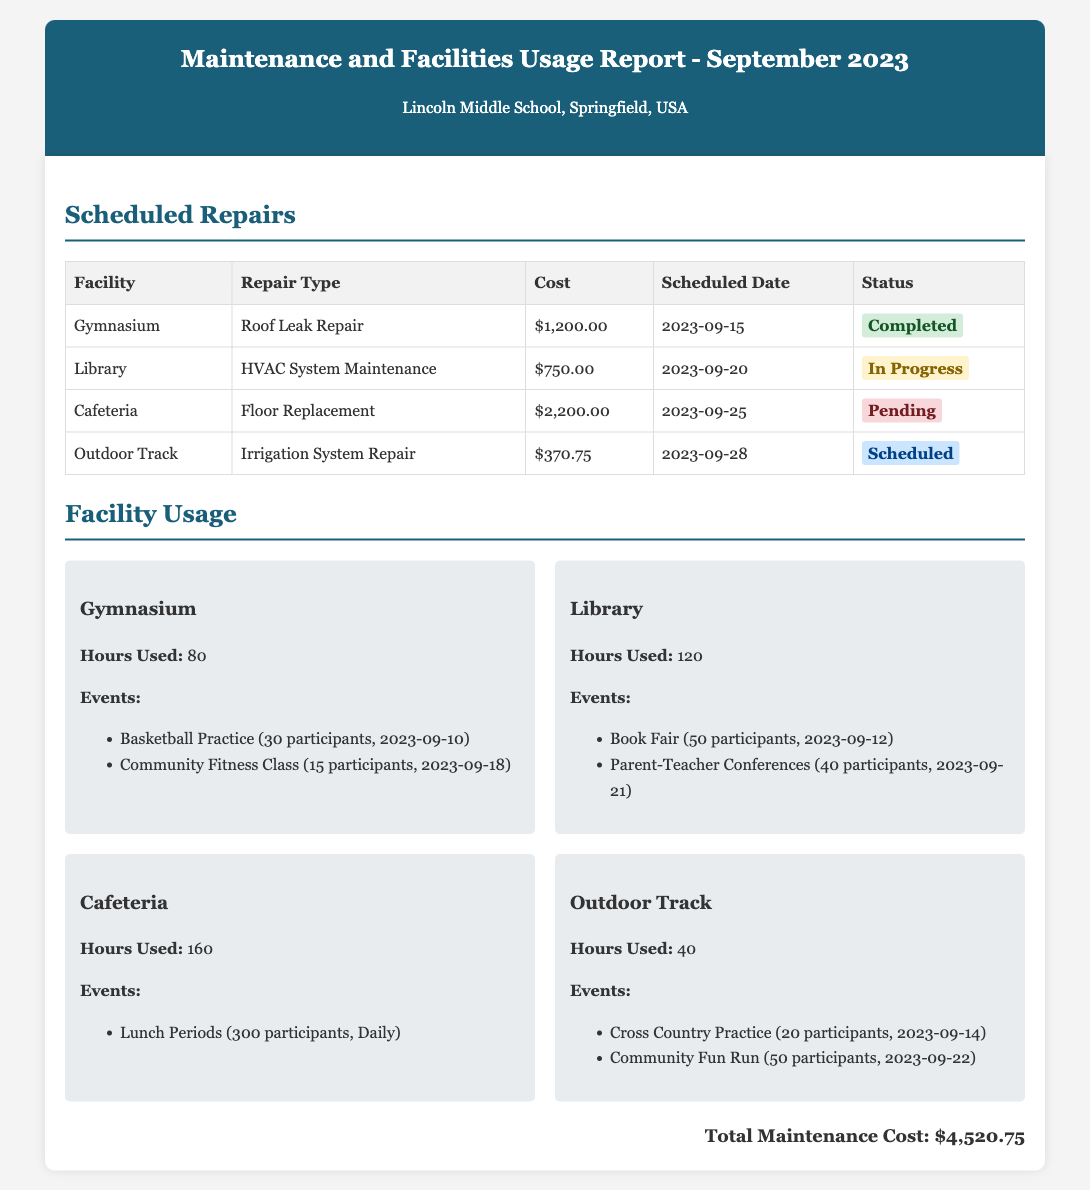what is the total maintenance cost? The total maintenance cost is listed at the bottom of the document, which sums all individual repair costs.
Answer: $4,520.75 how many hours did the Gymnasium get used? The document states that the Gymnasium was used for a specific number of hours.
Answer: 80 what type of repair is scheduled for the Cafeteria? The document lists the type of repair scheduled for the Cafeteria in the scheduled repairs section.
Answer: Floor Replacement when is the HVAC System Maintenance for the Library scheduled? The scheduled date for the HVAC System Maintenance is provided in the table for scheduled repairs.
Answer: 2023-09-20 how many participants attended the Book Fair event at the Library? The document provides details about attendance per event, specifically noting participant numbers.
Answer: 50 what is the status of the Irrigation System Repair for the Outdoor Track? The status of the scheduled repair is indicated in the status column of the scheduled repairs table.
Answer: Scheduled which facility had a completed repair in September? The document indicates which repair was completed by highlighting the status in the table.
Answer: Gymnasium what is the scheduled date for the Floor Replacement in the Cafeteria? The document lists the scheduled date specifically for the Floor Replacement repair.
Answer: 2023-09-25 how many events took place in the Cafeteria? The document details the uses of each facility, with specific entries for events held there.
Answer: 1 